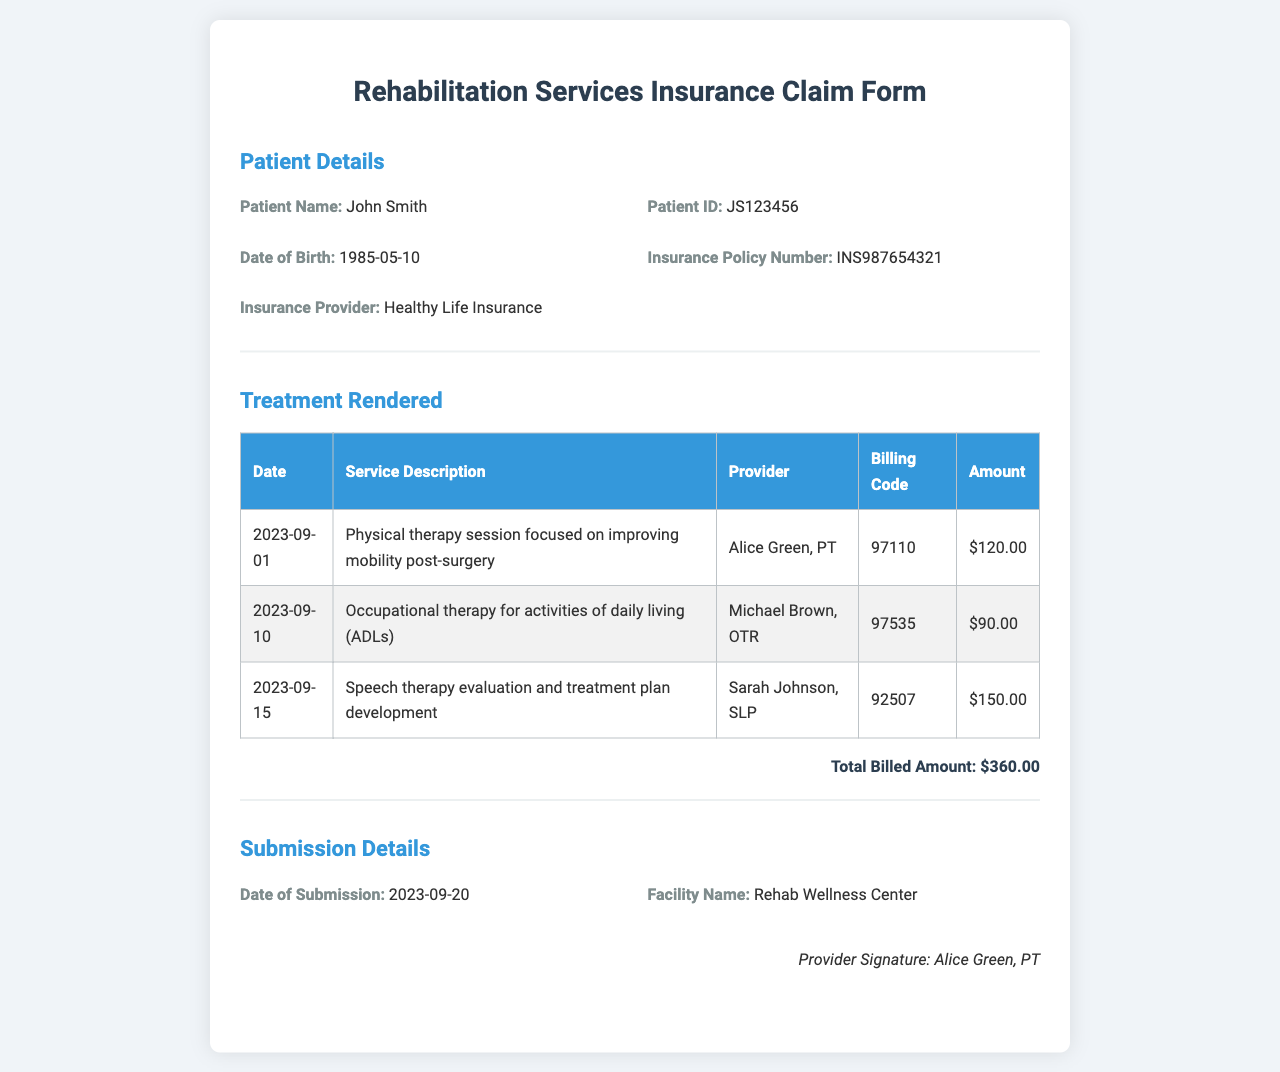What is the patient's name? The patient's name is listed in the Patient Details section of the document.
Answer: John Smith What is the total billed amount? The total billed amount is provided at the end of the Treatment Rendered section.
Answer: $360.00 Who provided the physical therapy session? The provider of the physical therapy session is mentioned in the Treatment Rendered section.
Answer: Alice Green, PT On what date was the occupational therapy performed? The date of the occupational therapy session is specified in the Treatment Rendered section.
Answer: 2023-09-10 What is the submission date of the insurance claim? The date of submission can be found in the Submission Details section.
Answer: 2023-09-20 What type of therapy was performed on September 15, 2023? The type of therapy performed on that date is included in the Treatment Rendered section of the document.
Answer: Speech therapy evaluation and treatment plan development How many therapy sessions are listed in the document? The number of therapy sessions can be counted from the Treatment Rendered table.
Answer: 3 What is the insurance provider's name? The name of the insurance provider is provided in the Patient Details section.
Answer: Healthy Life Insurance What is the billing code for occupational therapy? The billing code for occupational therapy is specified in the table under Treatment Rendered.
Answer: 97535 